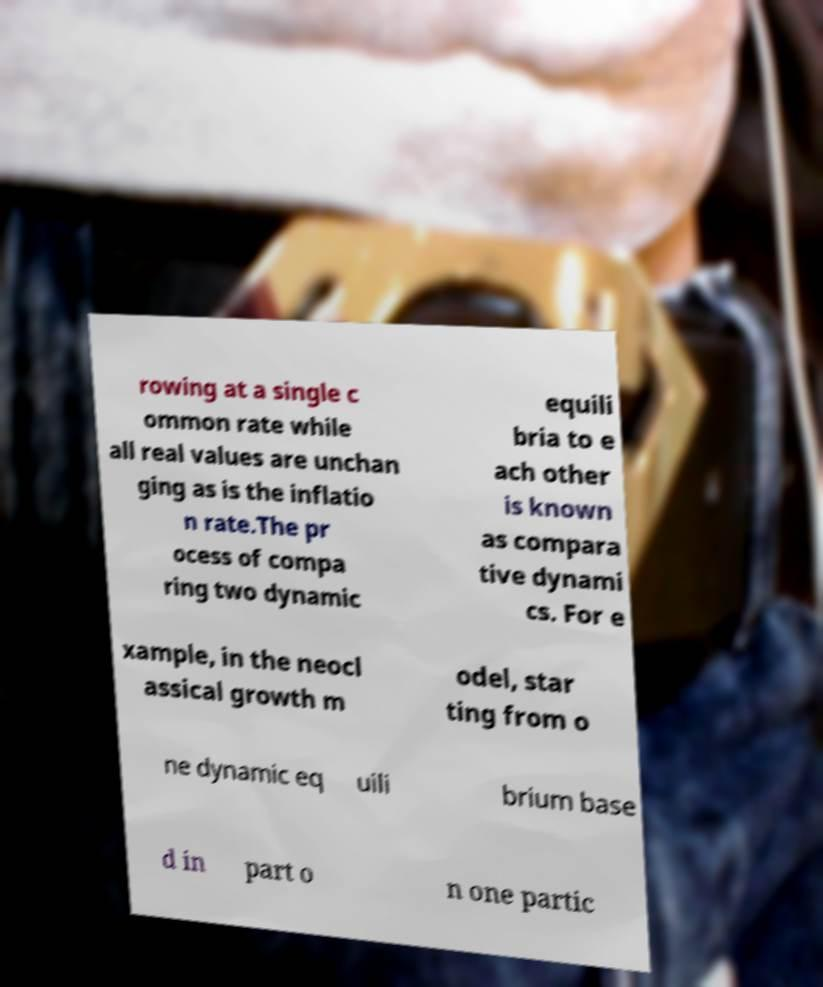Could you extract and type out the text from this image? rowing at a single c ommon rate while all real values are unchan ging as is the inflatio n rate.The pr ocess of compa ring two dynamic equili bria to e ach other is known as compara tive dynami cs. For e xample, in the neocl assical growth m odel, star ting from o ne dynamic eq uili brium base d in part o n one partic 